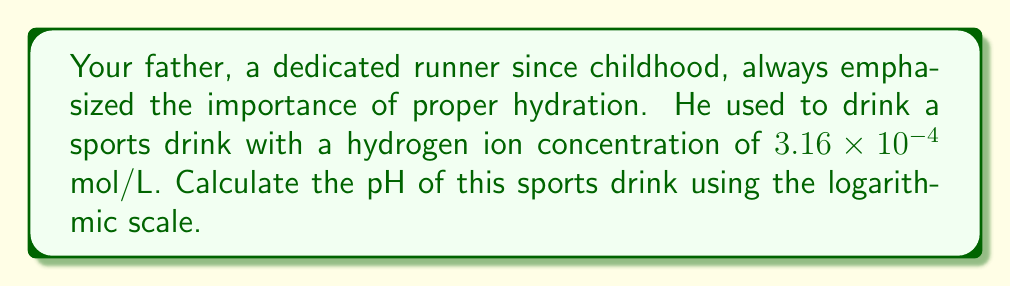Could you help me with this problem? Let's approach this step-by-step:

1) The pH scale is defined as the negative logarithm (base 10) of the hydrogen ion concentration [H+]:

   $$ pH = -\log_{10}[H^+] $$

2) We're given that the hydrogen ion concentration [H+] is $3.16 \times 10^{-4}$ mol/L.

3) Let's substitute this into our pH equation:

   $$ pH = -\log_{10}(3.16 \times 10^{-4}) $$

4) Using the properties of logarithms, we can split this into two parts:

   $$ pH = -(\log_{10}(3.16) + \log_{10}(10^{-4})) $$

5) We know that $\log_{10}(10^{-4}) = -4$, so:

   $$ pH = -(\log_{10}(3.16) - 4) $$

6) Using a calculator or logarithm table, we find that $\log_{10}(3.16) \approx 0.5$

7) Substituting this in:

   $$ pH = -(0.5 - 4) = -0.5 + 4 = 3.5 $$

Therefore, the pH of the sports drink is 3.5.
Answer: 3.5 